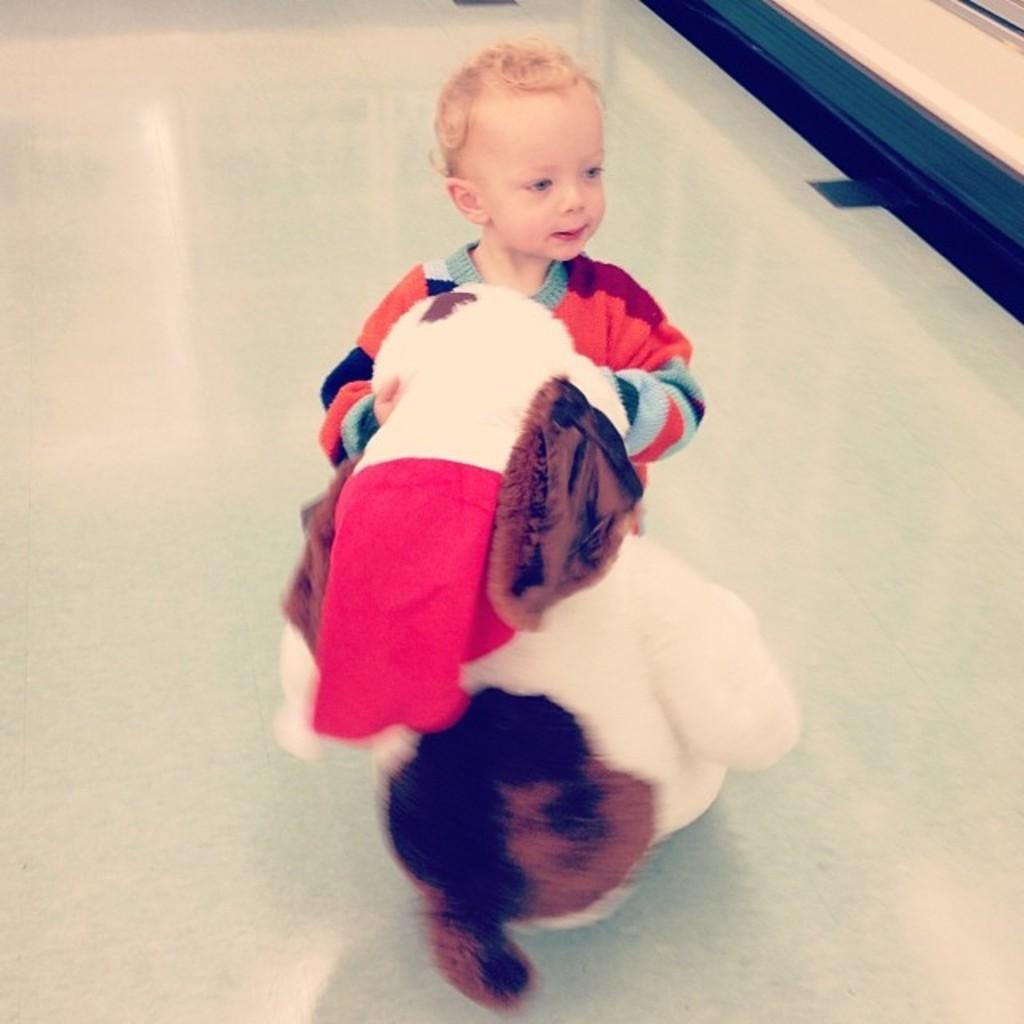Who is present in the image? There is a boy in the image. What is the boy doing in the image? The boy is standing in the image. What is the boy holding in the image? The boy is holding a white and brown color soft toy in the image. Can you describe the quality of the image? The image is slightly blurry. What type of hose is the boy using to water the plants in the image? There is no hose present in the image, and the boy is not watering any plants. 